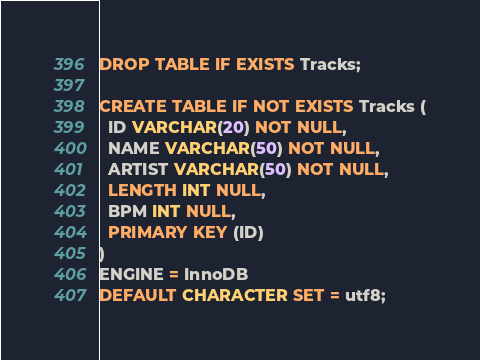Convert code to text. <code><loc_0><loc_0><loc_500><loc_500><_SQL_>DROP TABLE IF EXISTS Tracks;

CREATE TABLE IF NOT EXISTS Tracks (
  ID VARCHAR(20) NOT NULL,
  NAME VARCHAR(50) NOT NULL,
  ARTIST VARCHAR(50) NOT NULL,
  LENGTH INT NULL,
  BPM INT NULL,
  PRIMARY KEY (ID)
)
ENGINE = InnoDB
DEFAULT CHARACTER SET = utf8;
</code> 